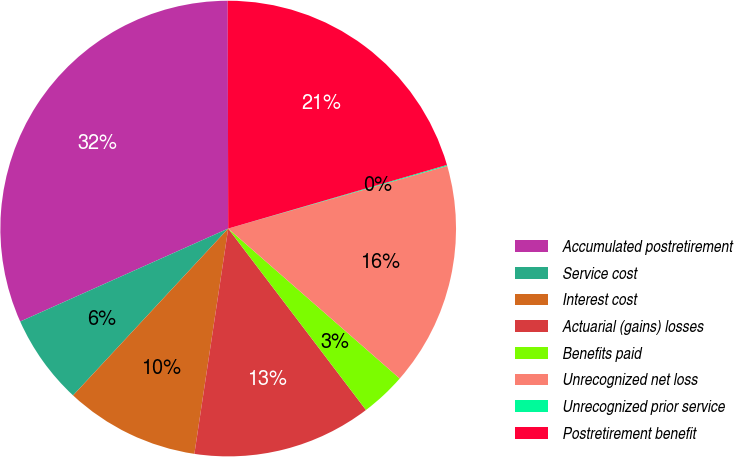Convert chart to OTSL. <chart><loc_0><loc_0><loc_500><loc_500><pie_chart><fcel>Accumulated postretirement<fcel>Service cost<fcel>Interest cost<fcel>Actuarial (gains) losses<fcel>Benefits paid<fcel>Unrecognized net loss<fcel>Unrecognized prior service<fcel>Postretirement benefit<nl><fcel>31.66%<fcel>6.39%<fcel>9.55%<fcel>12.71%<fcel>3.23%<fcel>15.87%<fcel>0.07%<fcel>20.53%<nl></chart> 